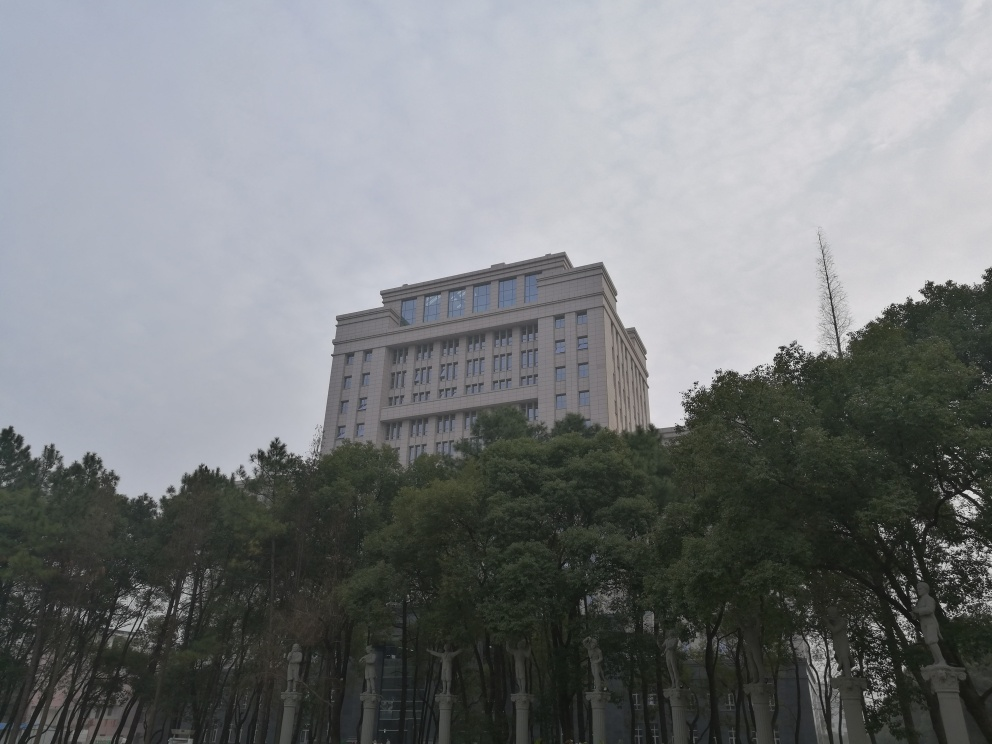What architectural style is reflected in the building in this image? The building in the image exhibits characteristics of modern architectural style, with its clean lines, symmetrical form, and use of what appears to be natural stone or concrete. Its grandiose façade and levelled design indicate that it may serve as an important commercial or administrative building. 